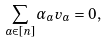Convert formula to latex. <formula><loc_0><loc_0><loc_500><loc_500>\sum _ { a \in [ n ] } \alpha _ { a } v _ { a } = 0 ,</formula> 